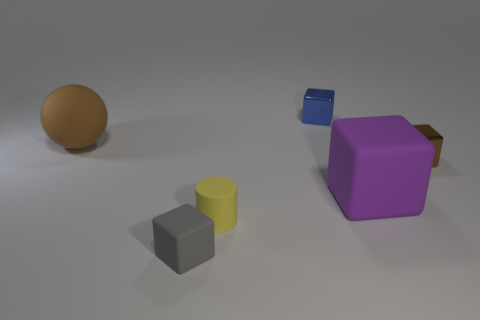How many metallic blocks are the same size as the brown ball?
Your response must be concise. 0. There is a small matte thing to the left of the tiny yellow object; does it have the same shape as the brown thing to the right of the big purple matte thing?
Provide a succinct answer. Yes. What is the shape of the small thing that is the same color as the large ball?
Keep it short and to the point. Cube. There is a big thing that is to the left of the big object on the right side of the tiny gray matte thing; what color is it?
Provide a short and direct response. Brown. What is the color of the other shiny object that is the same shape as the brown metallic thing?
Provide a succinct answer. Blue. Are there any other things that are made of the same material as the big sphere?
Keep it short and to the point. Yes. What is the size of the other metallic object that is the same shape as the brown shiny object?
Provide a succinct answer. Small. There is a big object that is left of the tiny gray cube; what is its material?
Ensure brevity in your answer.  Rubber. Is the number of tiny cylinders to the right of the tiny blue thing less than the number of tiny cubes?
Ensure brevity in your answer.  Yes. What is the shape of the brown object that is to the right of the blue metallic object that is behind the tiny brown object?
Your answer should be compact. Cube. 